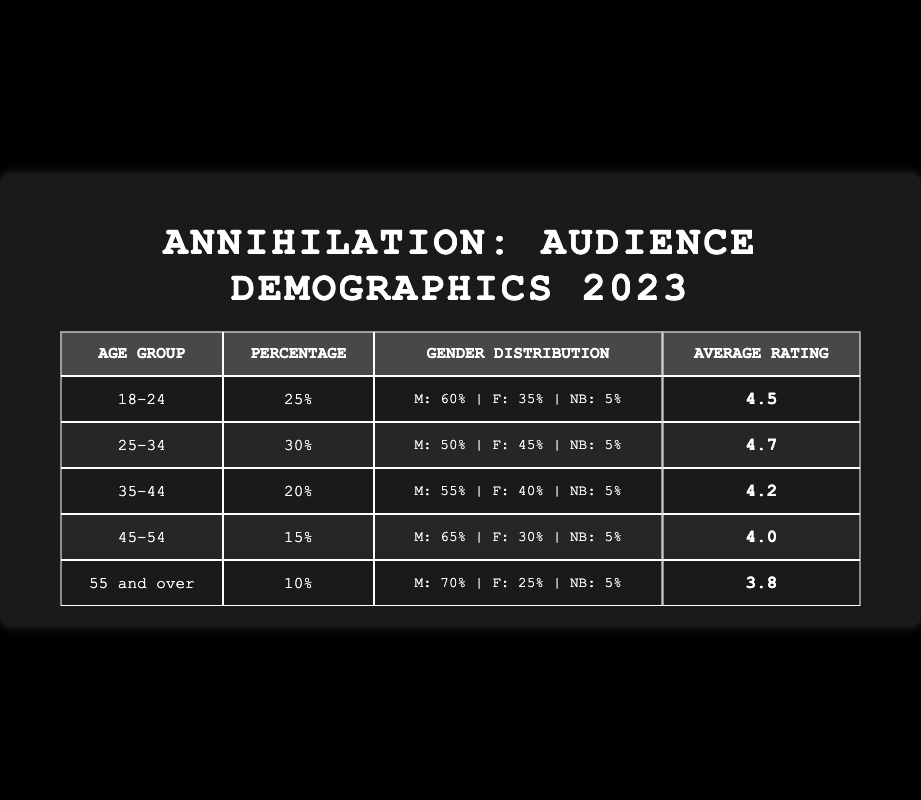What is the average rating of the 25-34 age group? The table indicates that the average rating for the 25-34 age group is 4.7.
Answer: 4.7 Which age group has the highest percentage of screenings? The 25-34 age group has the highest percentage of screenings at 30%.
Answer: 25-34 Is the average rating for the 55 and over group lower than 4.0? Yes, the average rating for the 55 and over group is 3.8, which is lower than 4.0.
Answer: Yes What is the total percentage of audiences aged 18-44? To find the total percentage for ages 18-44, we sum the percentages: 25% (18-24) + 30% (25-34) + 20% (35-44) = 75%.
Answer: 75% How does the percentage of female attendees in the 45-54 age group compare to those in the 55 and over group? In the 45-54 age group, the percentage of females is 30%, while it is 25% in the 55 and over group. Therefore, there are more females in the 45-54 age group than in the 55 and over group.
Answer: More in 45-54 What is the gender distribution percentage difference between males in the 18-24 and 55 and over age groups? The male percentage in the 18-24 age group is 60%, and in the 55 and over age group, it is 70%. The difference is 70% - 60% = 10%.
Answer: 10% Which age group shows the least favorable average rating? The 55 and over age group has the least favorable average rating at 3.8, compared to all other age groups.
Answer: 55 and over How many age groups have an average rating above 4.0? The age groups with an average rating above 4.0 are 18-24, 25-34, and 35-44. Counting these gives us three groups.
Answer: 3 What is the average rating for the combined age groups from 25-54? We calculate the average from groups 25-34 (4.7), 35-44 (4.2), and 45-54 (4.0): (4.7 + 4.2 + 4.0) / 3 = 4.33.
Answer: 4.33 Which gender has a higher representation in the 35-44 age group? Males have 55% representation while females have 40%, so males are higher represented in the 35-44 age group.
Answer: Males Is the percentage of non-binary viewers consistent across all age groups? Yes, the percentage of non-binary viewers is consistently 5% across all age groups listed in the table.
Answer: Yes 